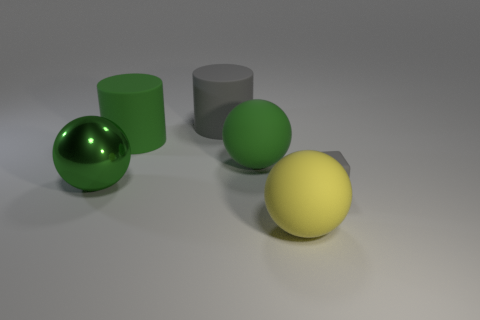Is the material of the small cube the same as the gray cylinder?
Your response must be concise. Yes. There is a rubber thing that is the same color as the small cube; what shape is it?
Make the answer very short. Cylinder. Does the big thing that is in front of the tiny matte object have the same color as the cube?
Make the answer very short. No. How many gray objects are on the left side of the gray thing on the right side of the yellow object?
Your response must be concise. 1. There is a metallic ball that is the same size as the gray matte cylinder; what color is it?
Make the answer very short. Green. There is a big thing in front of the tiny matte object; what is it made of?
Make the answer very short. Rubber. The large sphere that is on the right side of the green shiny ball and behind the small cube is made of what material?
Offer a very short reply. Rubber. Is the size of the matte thing in front of the gray cube the same as the large gray cylinder?
Give a very brief answer. Yes. The yellow matte object has what shape?
Your response must be concise. Sphere. How many large green objects are the same shape as the small gray rubber thing?
Offer a terse response. 0. 